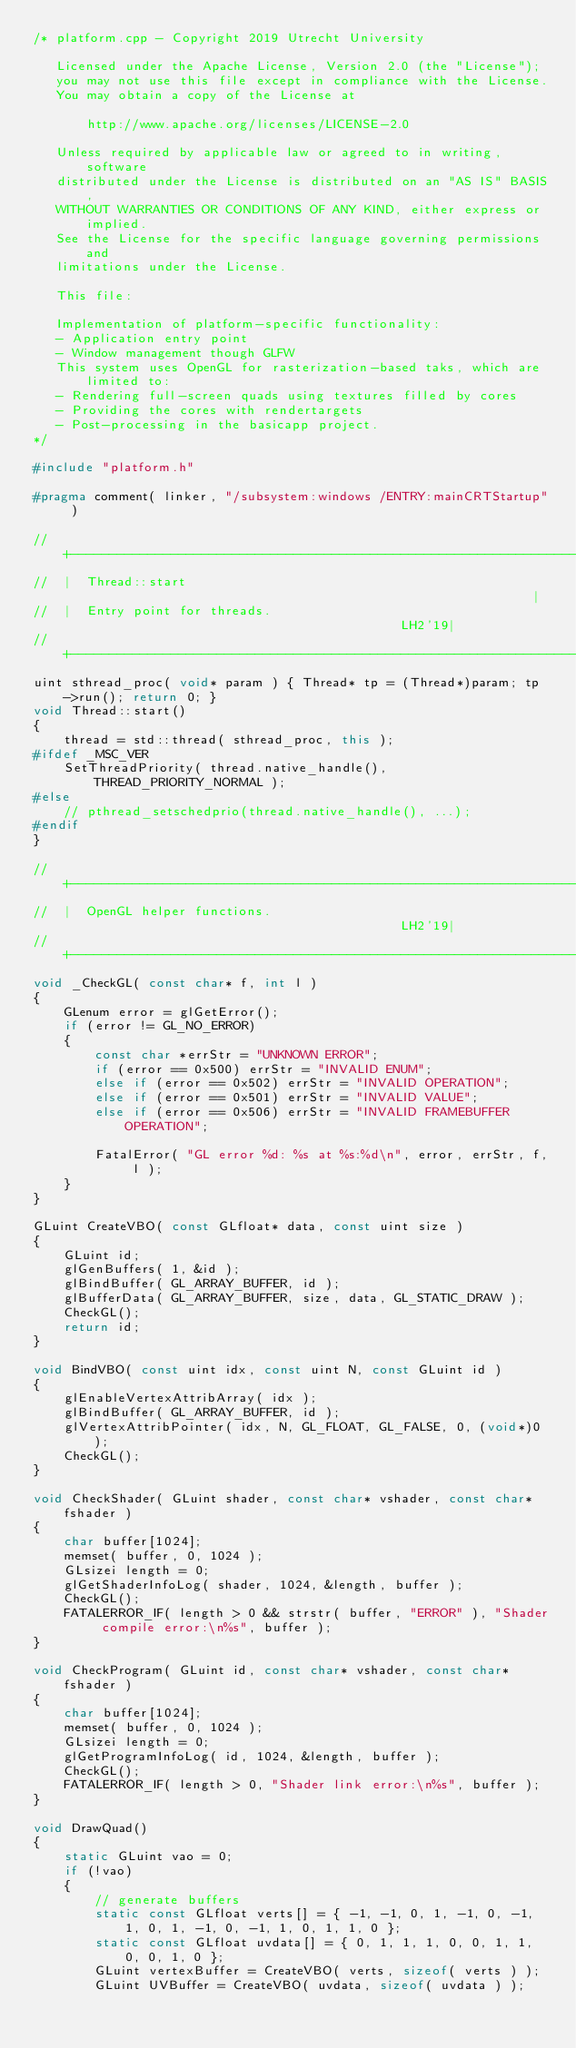Convert code to text. <code><loc_0><loc_0><loc_500><loc_500><_C++_>/* platform.cpp - Copyright 2019 Utrecht University

   Licensed under the Apache License, Version 2.0 (the "License");
   you may not use this file except in compliance with the License.
   You may obtain a copy of the License at

	   http://www.apache.org/licenses/LICENSE-2.0

   Unless required by applicable law or agreed to in writing, software
   distributed under the License is distributed on an "AS IS" BASIS,
   WITHOUT WARRANTIES OR CONDITIONS OF ANY KIND, either express or implied.
   See the License for the specific language governing permissions and
   limitations under the License.

   This file:

   Implementation of platform-specific functionality:
   - Application entry point
   - Window management though GLFW
   This system uses OpenGL for rasterization-based taks, which are limited to:
   - Rendering full-screen quads using textures filled by cores
   - Providing the cores with rendertargets
   - Post-processing in the basicapp project.
*/

#include "platform.h"

#pragma comment( linker, "/subsystem:windows /ENTRY:mainCRTStartup" )

//  +-----------------------------------------------------------------------------+
//  |  Thread::start                                                              |
//  |  Entry point for threads.                                             LH2'19|
//  +-----------------------------------------------------------------------------+
uint sthread_proc( void* param ) { Thread* tp = (Thread*)param; tp->run(); return 0; }
void Thread::start()
{
	thread = std::thread( sthread_proc, this );
#ifdef _MSC_VER
	SetThreadPriority( thread.native_handle(), THREAD_PRIORITY_NORMAL );
#else
	// pthread_setschedprio(thread.native_handle(), ...);
#endif
}

//  +-----------------------------------------------------------------------------+
//  |  OpenGL helper functions.                                             LH2'19|
//  +-----------------------------------------------------------------------------+
void _CheckGL( const char* f, int l )
{
	GLenum error = glGetError();
	if (error != GL_NO_ERROR)
	{
		const char *errStr = "UNKNOWN ERROR";
		if (error == 0x500) errStr = "INVALID ENUM";
		else if (error == 0x502) errStr = "INVALID OPERATION";
		else if (error == 0x501) errStr = "INVALID VALUE";
		else if (error == 0x506) errStr = "INVALID FRAMEBUFFER OPERATION";

		FatalError( "GL error %d: %s at %s:%d\n", error, errStr, f, l );
	}
}

GLuint CreateVBO( const GLfloat* data, const uint size )
{
	GLuint id;
	glGenBuffers( 1, &id );
	glBindBuffer( GL_ARRAY_BUFFER, id );
	glBufferData( GL_ARRAY_BUFFER, size, data, GL_STATIC_DRAW );
	CheckGL();
	return id;
}

void BindVBO( const uint idx, const uint N, const GLuint id )
{
	glEnableVertexAttribArray( idx );
	glBindBuffer( GL_ARRAY_BUFFER, id );
	glVertexAttribPointer( idx, N, GL_FLOAT, GL_FALSE, 0, (void*)0 );
	CheckGL();
}

void CheckShader( GLuint shader, const char* vshader, const char* fshader )
{
	char buffer[1024];
	memset( buffer, 0, 1024 );
	GLsizei length = 0;
	glGetShaderInfoLog( shader, 1024, &length, buffer );
	CheckGL();
	FATALERROR_IF( length > 0 && strstr( buffer, "ERROR" ), "Shader compile error:\n%s", buffer );
}

void CheckProgram( GLuint id, const char* vshader, const char* fshader )
{
	char buffer[1024];
	memset( buffer, 0, 1024 );
	GLsizei length = 0;
	glGetProgramInfoLog( id, 1024, &length, buffer );
	CheckGL();
	FATALERROR_IF( length > 0, "Shader link error:\n%s", buffer );
}

void DrawQuad()
{
	static GLuint vao = 0;
	if (!vao)
	{
		// generate buffers
		static const GLfloat verts[] = { -1, -1, 0, 1, -1, 0, -1, 1, 0, 1, -1, 0, -1, 1, 0, 1, 1, 0 };
		static const GLfloat uvdata[] = { 0, 1, 1, 1, 0, 0, 1, 1, 0, 0, 1, 0 };
		GLuint vertexBuffer = CreateVBO( verts, sizeof( verts ) );
		GLuint UVBuffer = CreateVBO( uvdata, sizeof( uvdata ) );</code> 